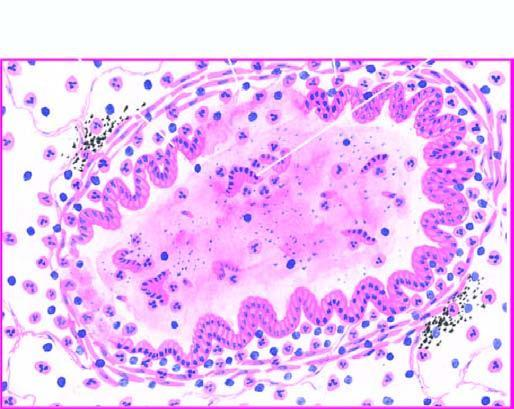what is sloughed off at places with exudate of muco-pus in the lumen?
Answer the question using a single word or phrase. Mucosa 